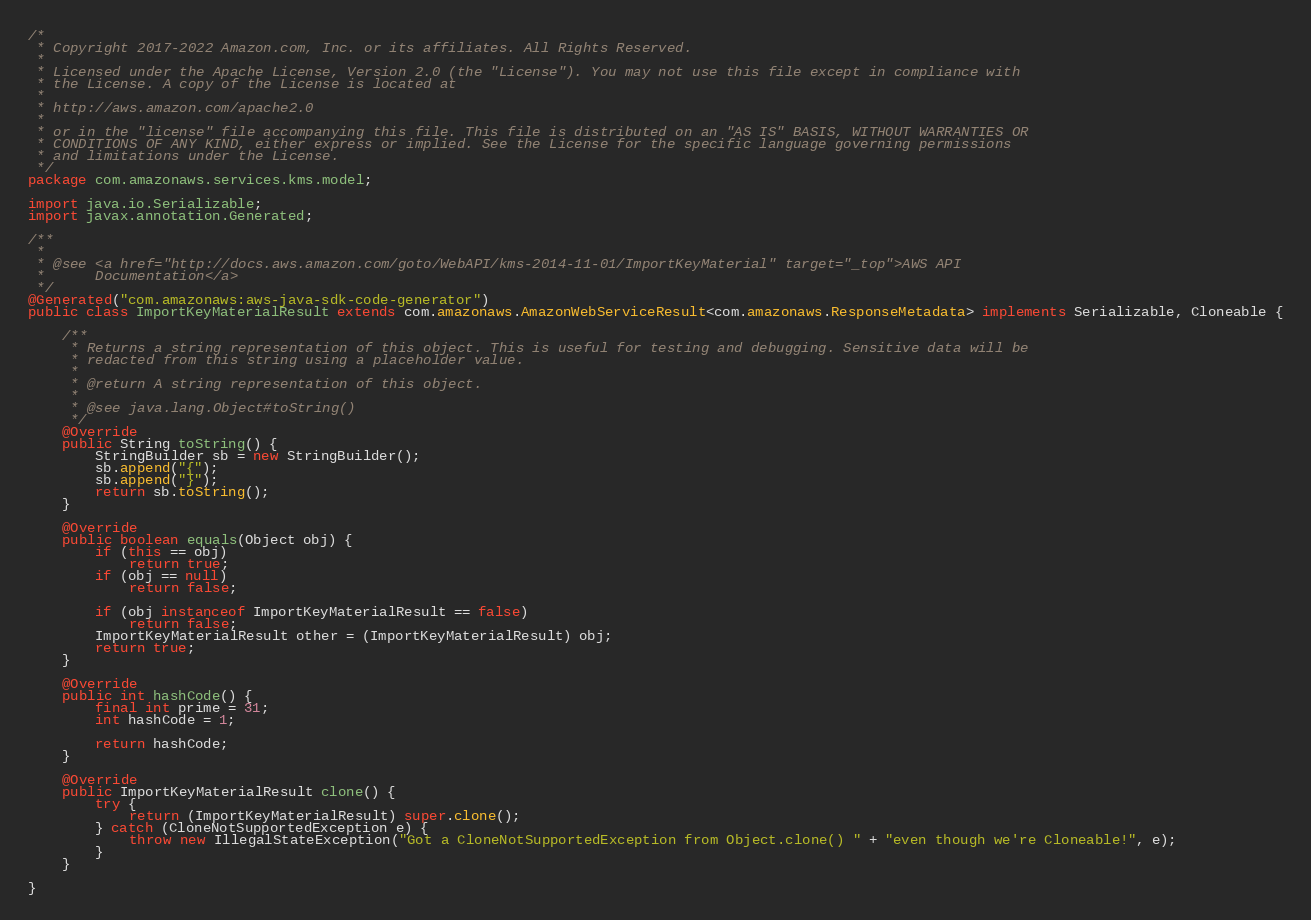Convert code to text. <code><loc_0><loc_0><loc_500><loc_500><_Java_>/*
 * Copyright 2017-2022 Amazon.com, Inc. or its affiliates. All Rights Reserved.
 * 
 * Licensed under the Apache License, Version 2.0 (the "License"). You may not use this file except in compliance with
 * the License. A copy of the License is located at
 * 
 * http://aws.amazon.com/apache2.0
 * 
 * or in the "license" file accompanying this file. This file is distributed on an "AS IS" BASIS, WITHOUT WARRANTIES OR
 * CONDITIONS OF ANY KIND, either express or implied. See the License for the specific language governing permissions
 * and limitations under the License.
 */
package com.amazonaws.services.kms.model;

import java.io.Serializable;
import javax.annotation.Generated;

/**
 * 
 * @see <a href="http://docs.aws.amazon.com/goto/WebAPI/kms-2014-11-01/ImportKeyMaterial" target="_top">AWS API
 *      Documentation</a>
 */
@Generated("com.amazonaws:aws-java-sdk-code-generator")
public class ImportKeyMaterialResult extends com.amazonaws.AmazonWebServiceResult<com.amazonaws.ResponseMetadata> implements Serializable, Cloneable {

    /**
     * Returns a string representation of this object. This is useful for testing and debugging. Sensitive data will be
     * redacted from this string using a placeholder value.
     *
     * @return A string representation of this object.
     *
     * @see java.lang.Object#toString()
     */
    @Override
    public String toString() {
        StringBuilder sb = new StringBuilder();
        sb.append("{");
        sb.append("}");
        return sb.toString();
    }

    @Override
    public boolean equals(Object obj) {
        if (this == obj)
            return true;
        if (obj == null)
            return false;

        if (obj instanceof ImportKeyMaterialResult == false)
            return false;
        ImportKeyMaterialResult other = (ImportKeyMaterialResult) obj;
        return true;
    }

    @Override
    public int hashCode() {
        final int prime = 31;
        int hashCode = 1;

        return hashCode;
    }

    @Override
    public ImportKeyMaterialResult clone() {
        try {
            return (ImportKeyMaterialResult) super.clone();
        } catch (CloneNotSupportedException e) {
            throw new IllegalStateException("Got a CloneNotSupportedException from Object.clone() " + "even though we're Cloneable!", e);
        }
    }

}
</code> 